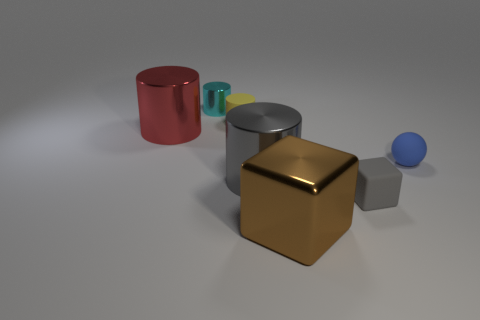Is there any other thing of the same color as the shiny cube?
Make the answer very short. No. What color is the other small thing that is the same shape as the small yellow object?
Your answer should be compact. Cyan. How big is the metal thing that is both behind the small rubber block and on the right side of the small cyan metal cylinder?
Offer a terse response. Large. Is the shape of the large object behind the matte ball the same as the metal thing that is in front of the tiny cube?
Provide a short and direct response. No. There is a big shiny thing that is the same color as the rubber cube; what is its shape?
Give a very brief answer. Cylinder. How many small cylinders have the same material as the blue thing?
Offer a terse response. 1. What is the shape of the object that is both in front of the small ball and to the left of the brown shiny object?
Your response must be concise. Cylinder. Is the block left of the tiny block made of the same material as the small blue ball?
Provide a succinct answer. No. What is the color of the rubber cube that is the same size as the blue rubber ball?
Provide a short and direct response. Gray. Are there any big cylinders that have the same color as the metal cube?
Provide a succinct answer. No. 